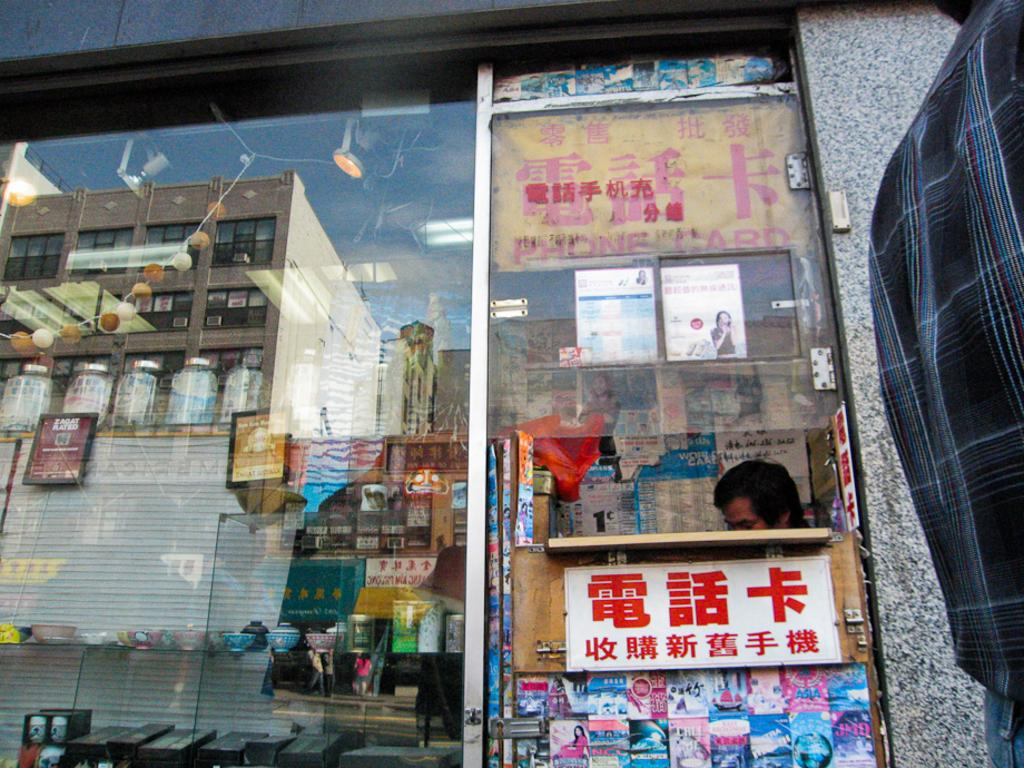<image>
Offer a succinct explanation of the picture presented. A storefront with a man inside with a sign for phonecards 